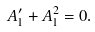<formula> <loc_0><loc_0><loc_500><loc_500>A ^ { \prime } _ { 1 } + A _ { 1 } ^ { 2 } = 0 .</formula> 